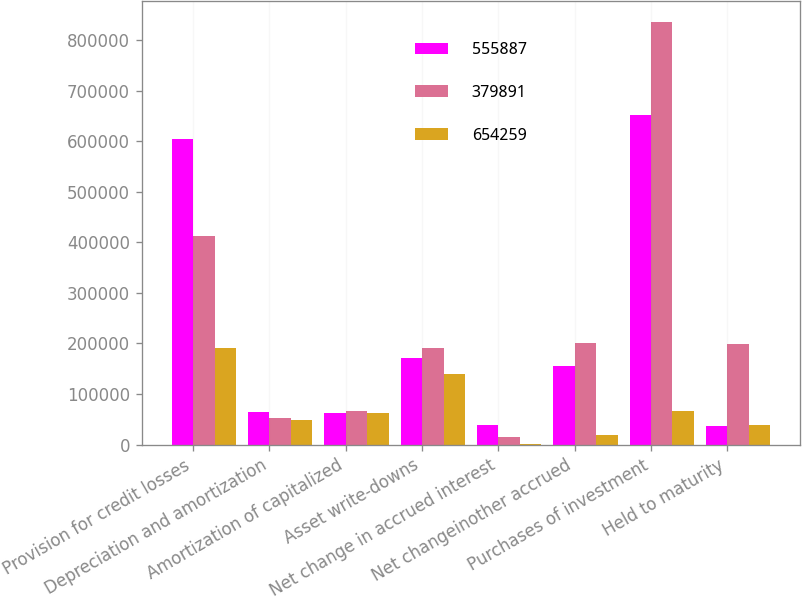Convert chart to OTSL. <chart><loc_0><loc_0><loc_500><loc_500><stacked_bar_chart><ecel><fcel>Provision for credit losses<fcel>Depreciation and amortization<fcel>Amortization of capitalized<fcel>Asset write-downs<fcel>Net change in accrued interest<fcel>Net changeinother accrued<fcel>Purchases of investment<fcel>Held to maturity<nl><fcel>555887<fcel>604000<fcel>64398<fcel>62268<fcel>171225<fcel>38920<fcel>154992<fcel>651549<fcel>37453<nl><fcel>379891<fcel>412000<fcel>53422<fcel>65722<fcel>190079<fcel>15023<fcel>201402<fcel>836448<fcel>198418<nl><fcel>654259<fcel>192000<fcel>48742<fcel>62931<fcel>139779<fcel>780<fcel>18461<fcel>65722<fcel>39588<nl></chart> 